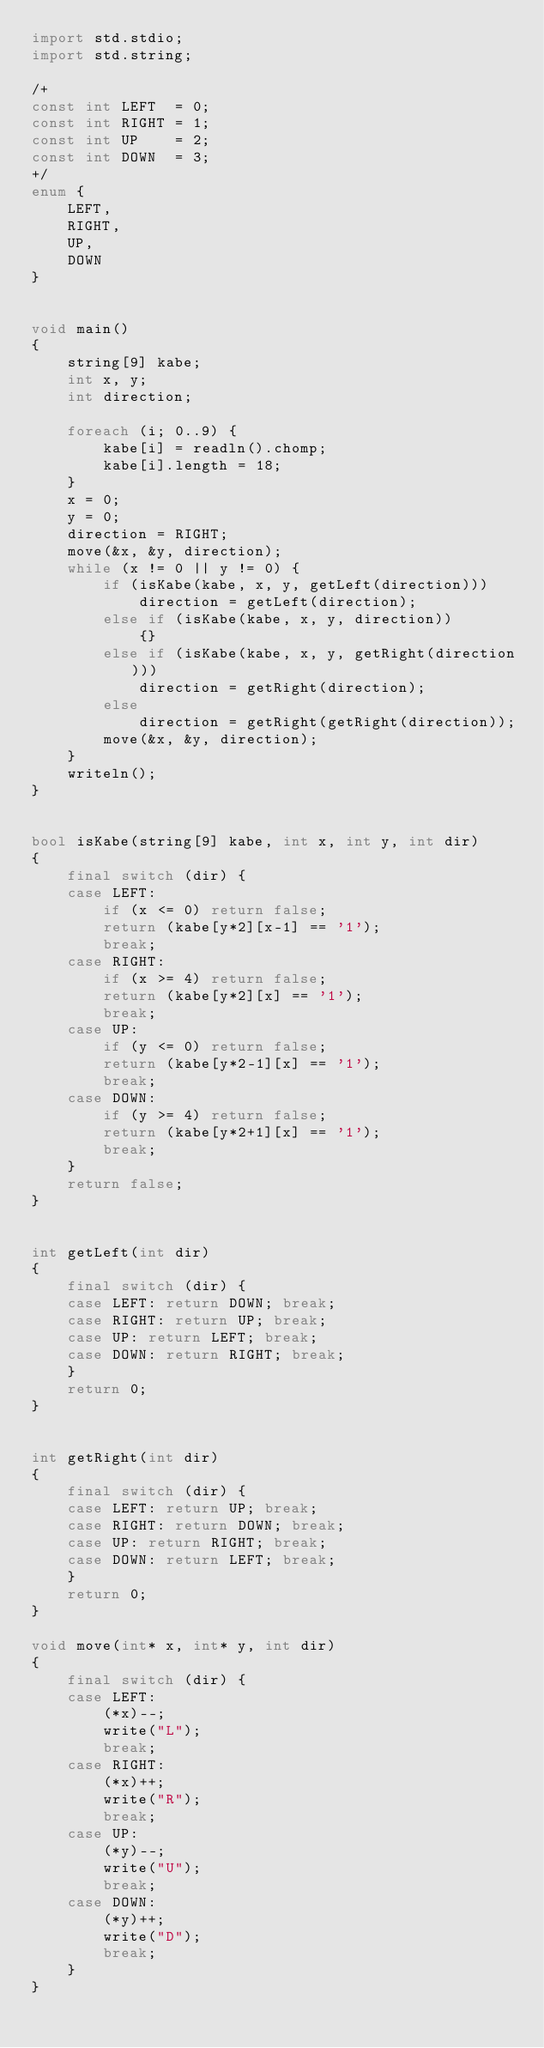<code> <loc_0><loc_0><loc_500><loc_500><_D_>import std.stdio;
import std.string;

/+
const int LEFT  = 0;
const int RIGHT = 1;
const int UP    = 2;
const int DOWN  = 3;
+/
enum {
    LEFT,
    RIGHT,
    UP,
    DOWN
}


void main()
{
    string[9] kabe;
    int x, y;
    int direction;

    foreach (i; 0..9) {
        kabe[i] = readln().chomp;
        kabe[i].length = 18;
    }
    x = 0;
    y = 0;
    direction = RIGHT;
    move(&x, &y, direction);
    while (x != 0 || y != 0) {
        if (isKabe(kabe, x, y, getLeft(direction)))
            direction = getLeft(direction);
        else if (isKabe(kabe, x, y, direction))
            {}
        else if (isKabe(kabe, x, y, getRight(direction)))
            direction = getRight(direction);
        else
            direction = getRight(getRight(direction));
        move(&x, &y, direction);
    }
    writeln();
}


bool isKabe(string[9] kabe, int x, int y, int dir)
{
    final switch (dir) {
    case LEFT:
        if (x <= 0) return false;
        return (kabe[y*2][x-1] == '1');
        break;
    case RIGHT:
        if (x >= 4) return false;
        return (kabe[y*2][x] == '1');
        break;
    case UP:
        if (y <= 0) return false;
        return (kabe[y*2-1][x] == '1');
        break;
    case DOWN:
        if (y >= 4) return false;
        return (kabe[y*2+1][x] == '1');
        break;
    }
    return false;
}


int getLeft(int dir)
{
    final switch (dir) {
    case LEFT: return DOWN; break;
    case RIGHT: return UP; break;
    case UP: return LEFT; break;
    case DOWN: return RIGHT; break;
    }
    return 0;
}


int getRight(int dir)
{
    final switch (dir) {
    case LEFT: return UP; break;
    case RIGHT: return DOWN; break;
    case UP: return RIGHT; break;
    case DOWN: return LEFT; break;
    }
    return 0;
}

void move(int* x, int* y, int dir)
{
    final switch (dir) {
    case LEFT:
        (*x)--;
        write("L");
        break;
    case RIGHT:
        (*x)++;
        write("R");
        break;
    case UP:
        (*y)--;
        write("U");
        break;
    case DOWN:
        (*y)++;
        write("D");
        break;
    }
}</code> 